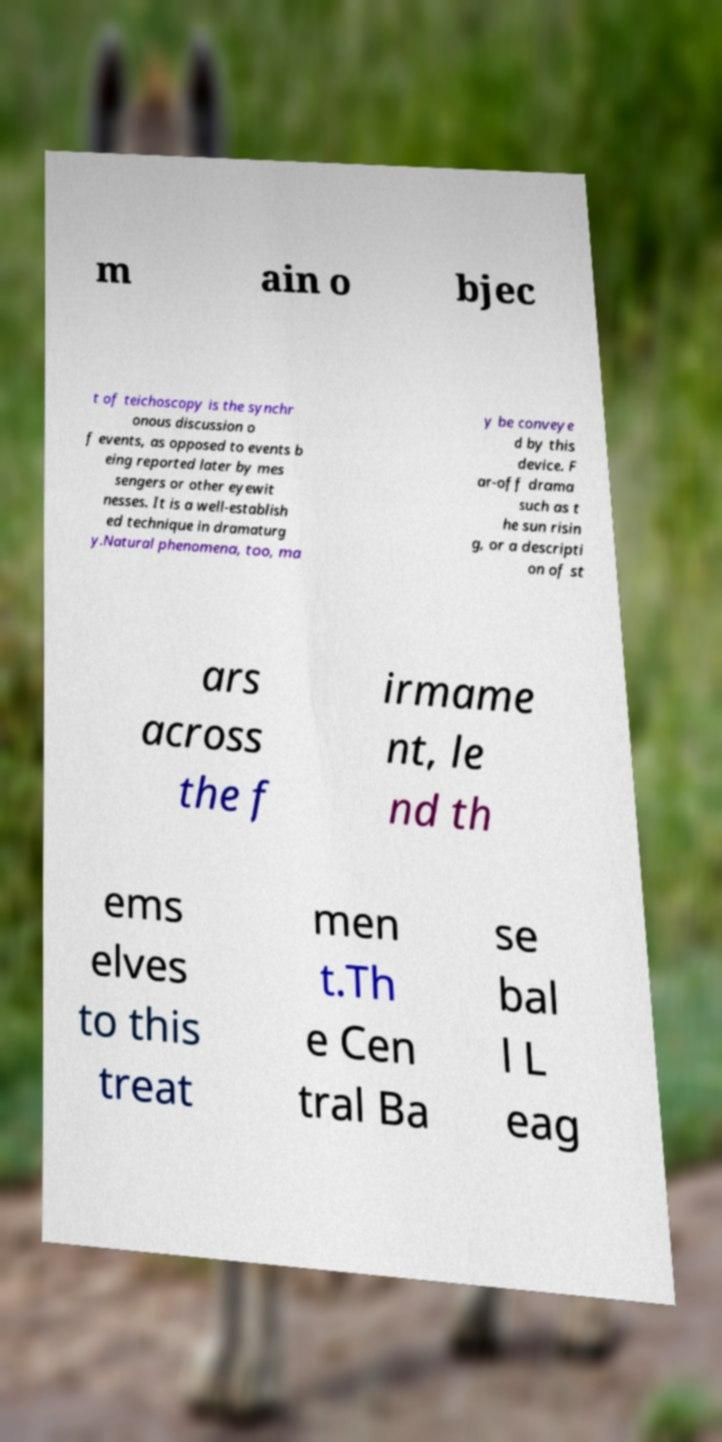Please identify and transcribe the text found in this image. m ain o bjec t of teichoscopy is the synchr onous discussion o f events, as opposed to events b eing reported later by mes sengers or other eyewit nesses. It is a well-establish ed technique in dramaturg y.Natural phenomena, too, ma y be conveye d by this device. F ar-off drama such as t he sun risin g, or a descripti on of st ars across the f irmame nt, le nd th ems elves to this treat men t.Th e Cen tral Ba se bal l L eag 